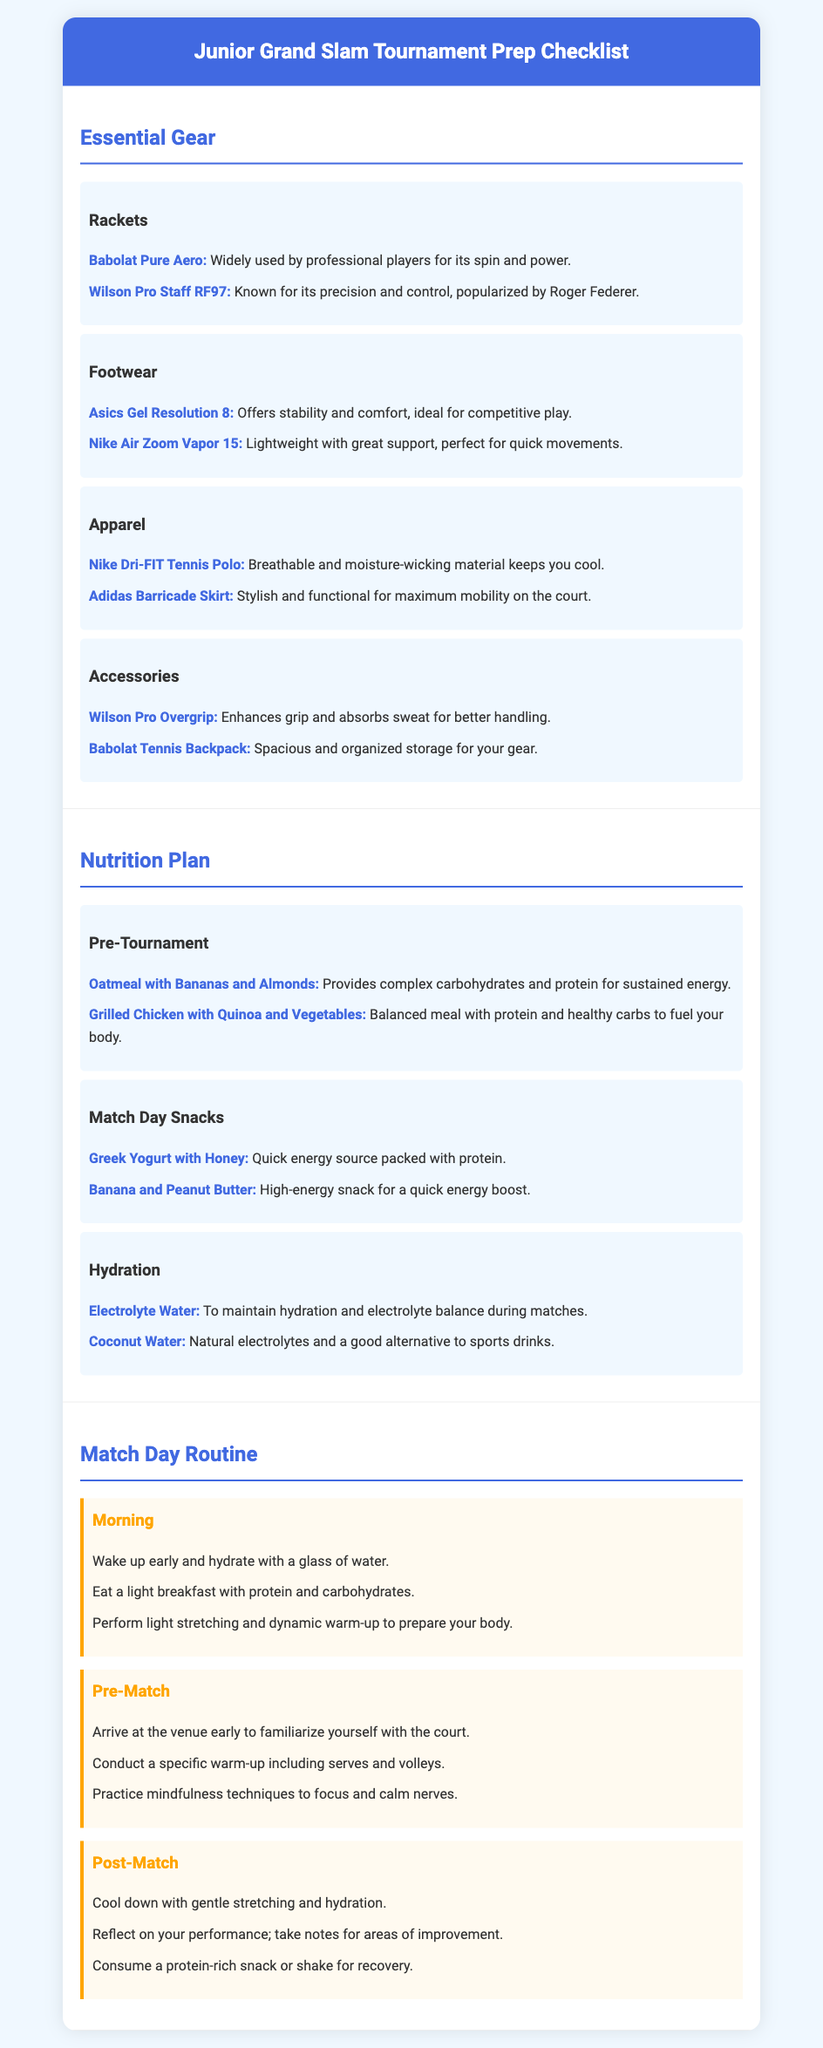What are the racket recommendations? The document lists two recommended rackets, which are the Babolat Pure Aero and the Wilson Pro Staff RF97.
Answer: Babolat Pure Aero, Wilson Pro Staff RF97 What type of footwear is recommended? The footwear section suggests the Asics Gel Resolution 8 and the Nike Air Zoom Vapor 15 for competitive play.
Answer: Asics Gel Resolution 8, Nike Air Zoom Vapor 15 What is a key pre-tournament meal? The nutrition plan highlights oatmeal with bananas and almonds as a key meal to provide energy.
Answer: Oatmeal with Bananas and Almonds What is a suggested pre-match activity? The document recommends arriving early to familiarize yourself with the court as a pre-match activity.
Answer: Familiarize yourself with the court How should you hydrate on match day? The hydration section suggests consuming electrolyte water and coconut water to maintain hydration.
Answer: Electrolyte Water, Coconut Water What is indicated for post-match recovery? The post-match routine includes consuming a protein-rich snack or shake for recovery.
Answer: Protein-rich snack or shake How many types of gear are listed? The document categorizes gear into four types: rackets, footwear, apparel, and accessories.
Answer: Four What should be performed during the morning routine? The morning routine suggests performing light stretching and a dynamic warm-up.
Answer: Light stretching and dynamic warm-up What is emphasized in the nutrition plan for match day? The nutrition plan emphasizes quick energy snacks like Greek yogurt with honey and banana with peanut butter on match day.
Answer: Greek Yogurt with Honey, Banana and Peanut Butter 